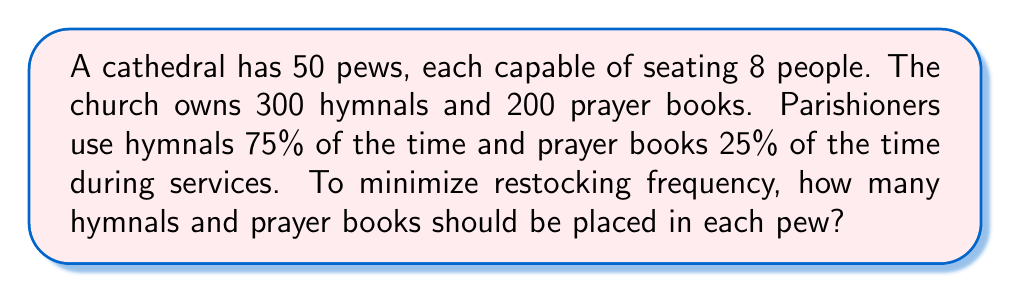Give your solution to this math problem. Let's approach this step-by-step:

1) First, we need to determine the total number of books needed:
   Total seats = 50 pews × 8 people = 400 seats

2) Ideal distribution based on usage:
   Hymnals: 400 × 75% = 300
   Prayer books: 400 × 25% = 100

3) However, we're constrained by the actual number of books available:
   300 hymnals (matches ideal)
   200 prayer books (exceeds ideal)

4) To minimize restocking, we should distribute all available books:
   Total books to distribute = 300 + 200 = 500

5) Books per pew:
   $$ \text{Books per pew} = \frac{\text{Total books}}{\text{Number of pews}} = \frac{500}{50} = 10 $$

6) Now, we need to determine the optimal split between hymnals and prayer books per pew:
   Let $x$ be the number of hymnals per pew.
   Then, $10-x$ will be the number of prayer books per pew.

7) To maintain the usage ratio as closely as possible:
   $$ \frac{x}{10-x} = \frac{3}{1} $$

8) Solving this equation:
   $$ x = 7.5 \text{ and } 10-x = 2.5 $$

9) Since we can't have fractional books, we round to the nearest whole number:
   7 hymnals and 3 prayer books per pew

10) Check total distribution:
    Hymnals: 7 × 50 = 350 (exceeds available, so we'll adjust)
    Prayer books: 3 × 50 = 150 (within available)

11) Final adjustment:
    Hymnals: 300 ÷ 50 = 6 per pew
    Prayer books: 200 ÷ 50 = 4 per pew
Answer: The optimal distribution is 6 hymnals and 4 prayer books per pew. 